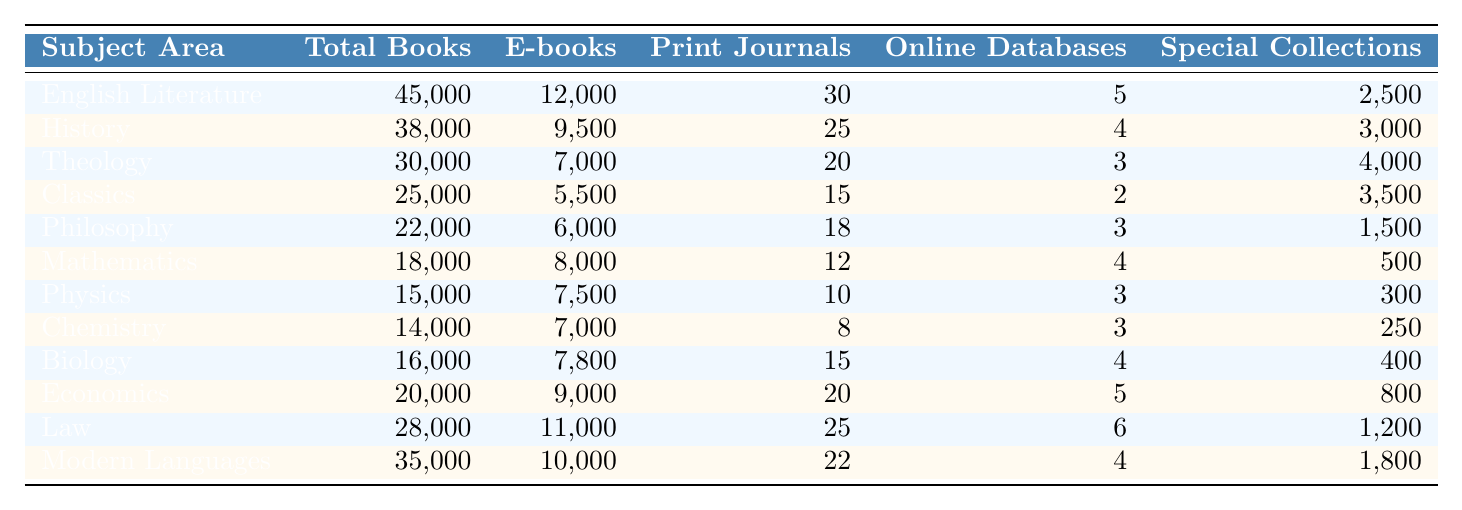What is the total number of books in the English Literature subject area? The English Literature subject area has a total of 45,000 books, as indicated in the table under the "Total Books" column.
Answer: 45,000 How many e-books are available in the Law subject area? In the Law subject area, there are 11,000 e-books listed in the table under the "E-books" column.
Answer: 11,000 Which subject area has the highest number of print journals? The English Literature subject area has the highest number of print journals at 30, as shown in the "Print Journals" column.
Answer: English Literature What is the difference in total books between Biology and Chemistry? Biology has 16,000 total books and Chemistry has 14,000; the difference is 16,000 - 14,000 = 2,000.
Answer: 2,000 What is the total number of e-books across all subjects? To find the total number of e-books, add all the e-books: 12,000 + 9,500 + 7,000 + 5,500 + 6,000 + 8,000 + 7,500 + 7,000 + 7,800 + 9,000 + 11,000 + 10,000 = 99,300.
Answer: 99,300 Is there any subject area with more than 25,000 total books? Yes, the subjects with more than 25,000 total books are English Literature, History, Theology, Law, and Modern Languages, as their totals exceed that value.
Answer: Yes Which subject area has the fewest special collections? The Mathematics subject area has the fewest special collections with only 500 listed in the table under "Special Collections."
Answer: Mathematics What is the average number of print journals across all subject areas? Calculate the average by summing print journals: (30 + 25 + 20 + 15 + 18 + 12 + 10 + 8 + 15 + 20 + 25 + 22) = 225; there are 12 subject areas, so the average is 225 / 12 = 18.75.
Answer: 18.75 How many total books are in the subject area with the least number of e-books? Chemistry has the least number of e-books at 7,000 with total books of 14,000.
Answer: 14,000 What percentage of total books in Theology are e-books? To find the percentage of e-books in Theology, divide the number of e-books (7,000) by total books (30,000), then multiply by 100: (7,000 / 30,000) * 100 = 23.33%.
Answer: 23.33% 